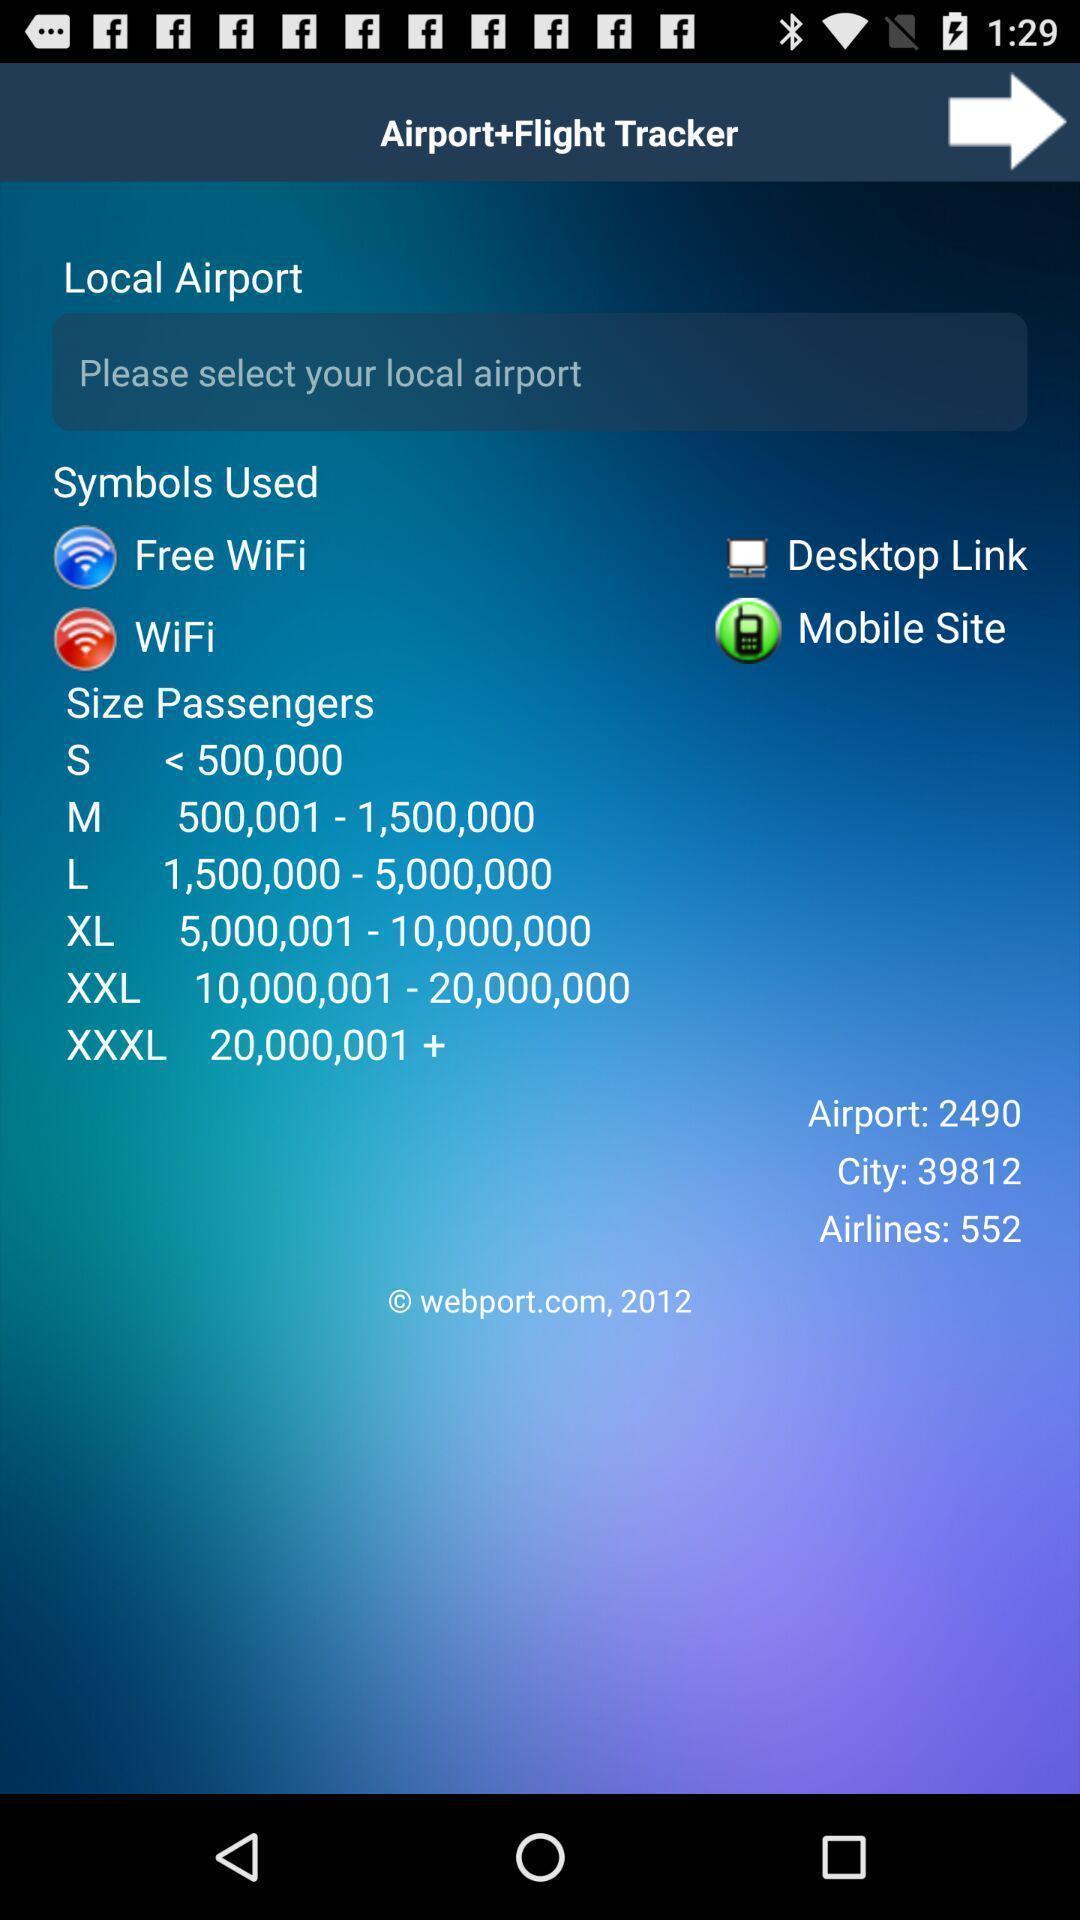What is the overall content of this screenshot? Search page for finding local airport on tracking app. 